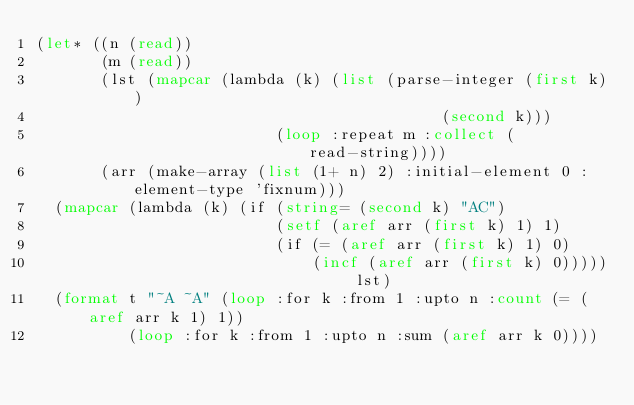Convert code to text. <code><loc_0><loc_0><loc_500><loc_500><_Lisp_>(let* ((n (read))
       (m (read))
       (lst (mapcar (lambda (k) (list (parse-integer (first k))
                                            (second k)))
                          (loop :repeat m :collect (read-string))))
       (arr (make-array (list (1+ n) 2) :initial-element 0 :element-type 'fixnum)))
  (mapcar (lambda (k) (if (string= (second k) "AC")
                          (setf (aref arr (first k) 1) 1)
                          (if (= (aref arr (first k) 1) 0)
                              (incf (aref arr (first k) 0))))) lst)
  (format t "~A ~A" (loop :for k :from 1 :upto n :count (= (aref arr k 1) 1))
          (loop :for k :from 1 :upto n :sum (aref arr k 0))))</code> 